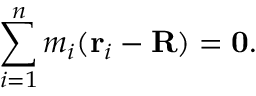Convert formula to latex. <formula><loc_0><loc_0><loc_500><loc_500>\sum _ { i = 1 } ^ { n } m _ { i } ( r _ { i } - R ) = 0 .</formula> 